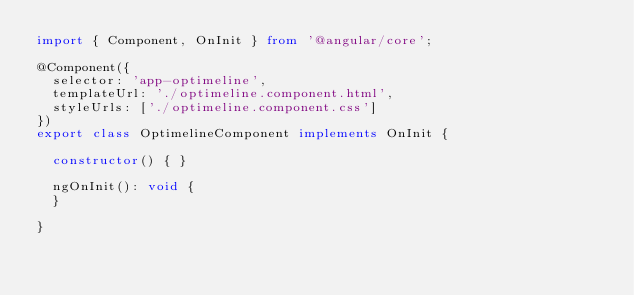Convert code to text. <code><loc_0><loc_0><loc_500><loc_500><_TypeScript_>import { Component, OnInit } from '@angular/core';

@Component({
  selector: 'app-optimeline',
  templateUrl: './optimeline.component.html',
  styleUrls: ['./optimeline.component.css']
})
export class OptimelineComponent implements OnInit {

  constructor() { }

  ngOnInit(): void {
  }

}
</code> 